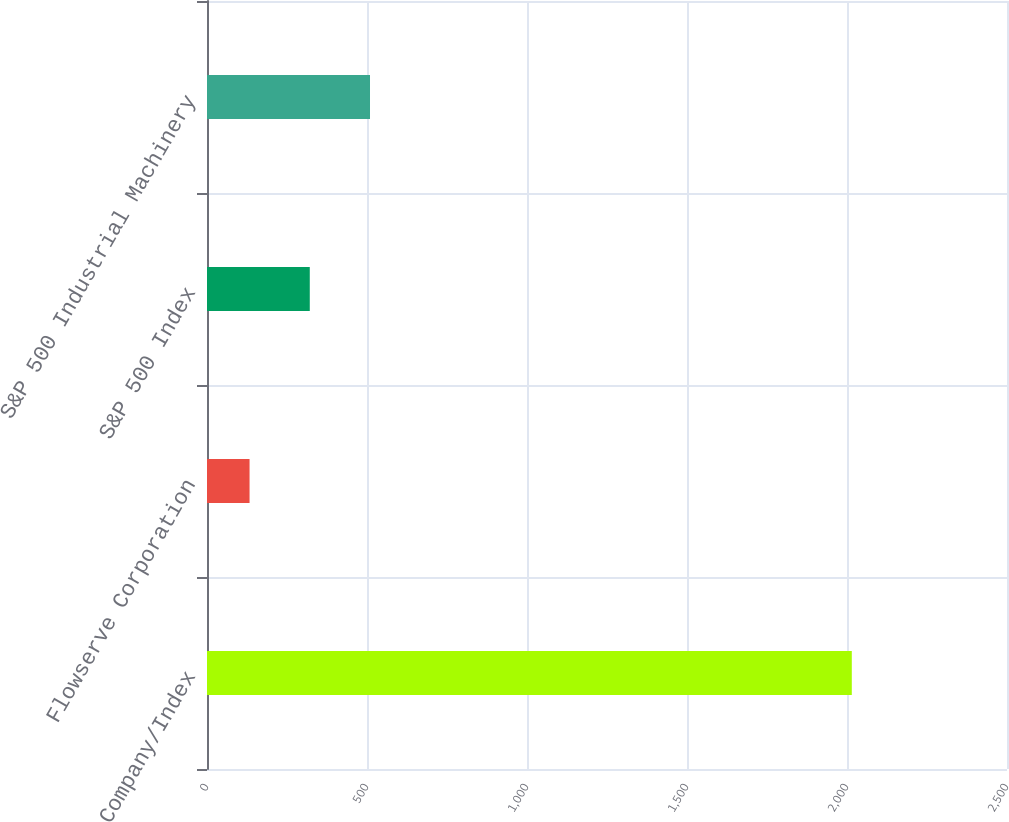Convert chart. <chart><loc_0><loc_0><loc_500><loc_500><bar_chart><fcel>Company/Index<fcel>Flowserve Corporation<fcel>S&P 500 Index<fcel>S&P 500 Industrial Machinery<nl><fcel>2015<fcel>132.99<fcel>321.19<fcel>509.39<nl></chart> 